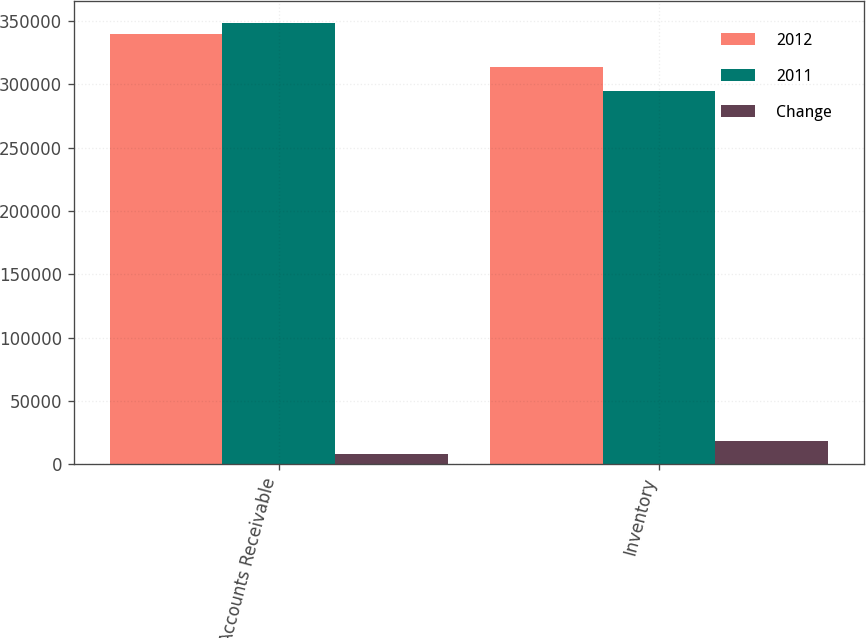<chart> <loc_0><loc_0><loc_500><loc_500><stacked_bar_chart><ecel><fcel>Accounts Receivable<fcel>Inventory<nl><fcel>2012<fcel>339881<fcel>313723<nl><fcel>2011<fcel>348416<fcel>295081<nl><fcel>Change<fcel>8535<fcel>18642<nl></chart> 